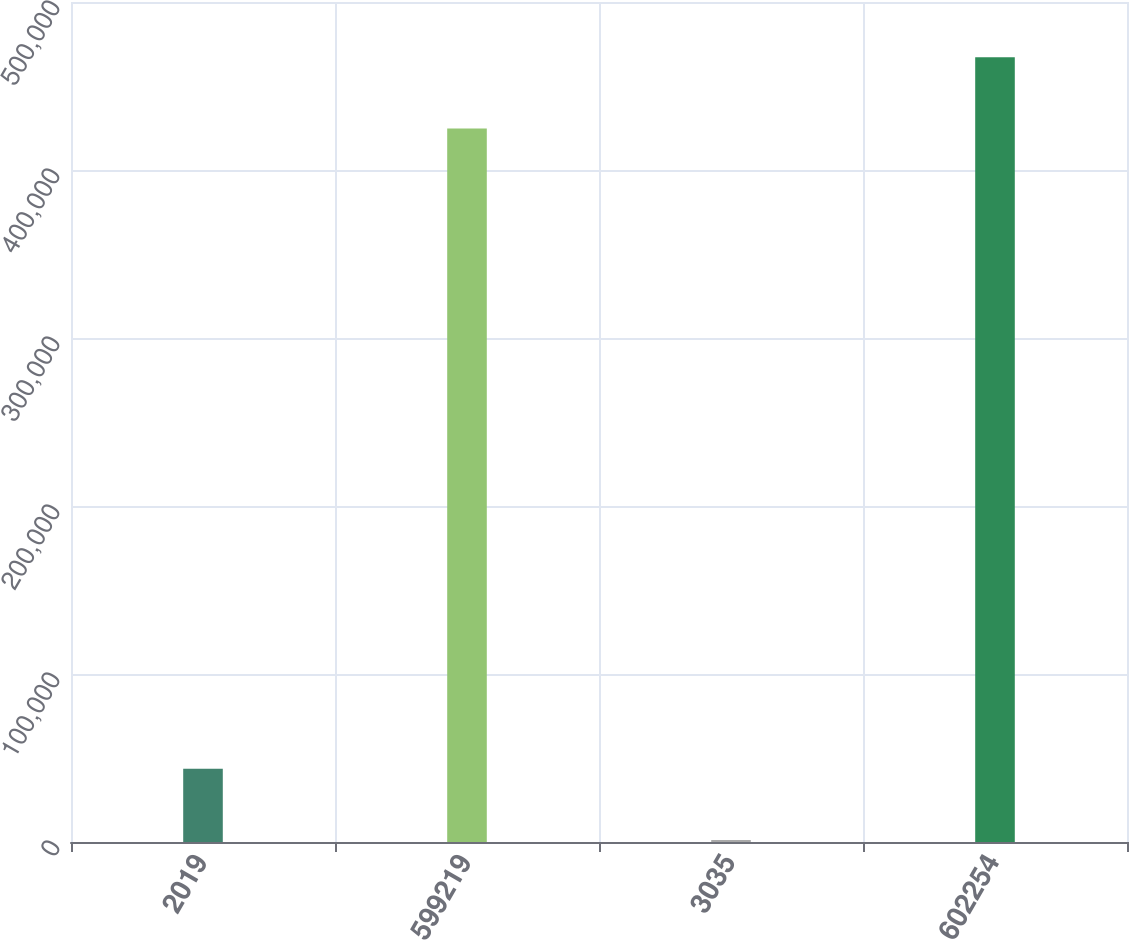Convert chart to OTSL. <chart><loc_0><loc_0><loc_500><loc_500><bar_chart><fcel>2019<fcel>599219<fcel>3035<fcel>602254<nl><fcel>43657.7<fcel>424707<fcel>1187<fcel>467178<nl></chart> 